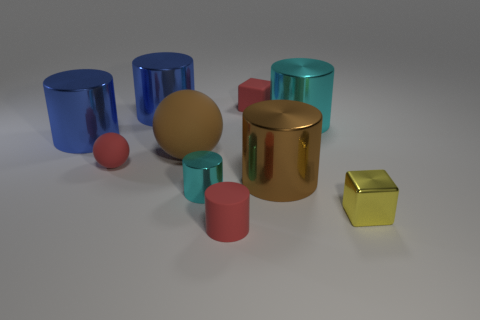Are there an equal number of small yellow metal cubes that are on the left side of the shiny cube and large spheres left of the big cyan cylinder?
Keep it short and to the point. No. There is a red object to the left of the small red rubber thing in front of the tiny yellow metal thing; what is its material?
Your answer should be compact. Rubber. What number of things are either matte cylinders or large brown cylinders?
Provide a short and direct response. 2. The sphere that is the same color as the small rubber cube is what size?
Your response must be concise. Small. Are there fewer small rubber cylinders than blue rubber blocks?
Provide a succinct answer. No. There is a red sphere that is the same material as the brown ball; what size is it?
Provide a short and direct response. Small. How big is the red cube?
Ensure brevity in your answer.  Small. What shape is the yellow shiny object?
Ensure brevity in your answer.  Cube. There is a small matte thing that is to the right of the red cylinder; does it have the same color as the tiny metallic cylinder?
Offer a terse response. No. The other matte thing that is the same shape as the large brown matte thing is what size?
Your response must be concise. Small. 